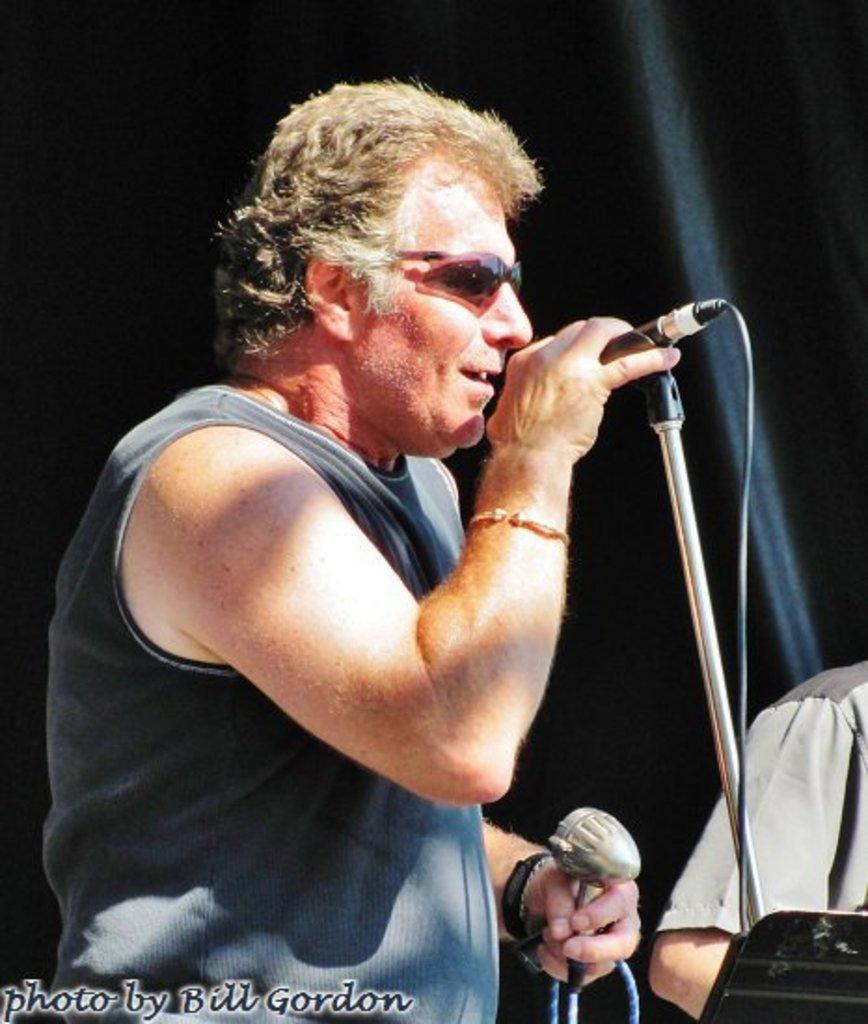Please provide a concise description of this image. Here in this picture we can see a person singing song in the microphone present in his hand, which is present on the stand over there and we can see he is wearing goggles on him and beside him also we can see another person also standing over there. 